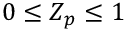Convert formula to latex. <formula><loc_0><loc_0><loc_500><loc_500>0 \leq Z _ { p } \leq 1</formula> 